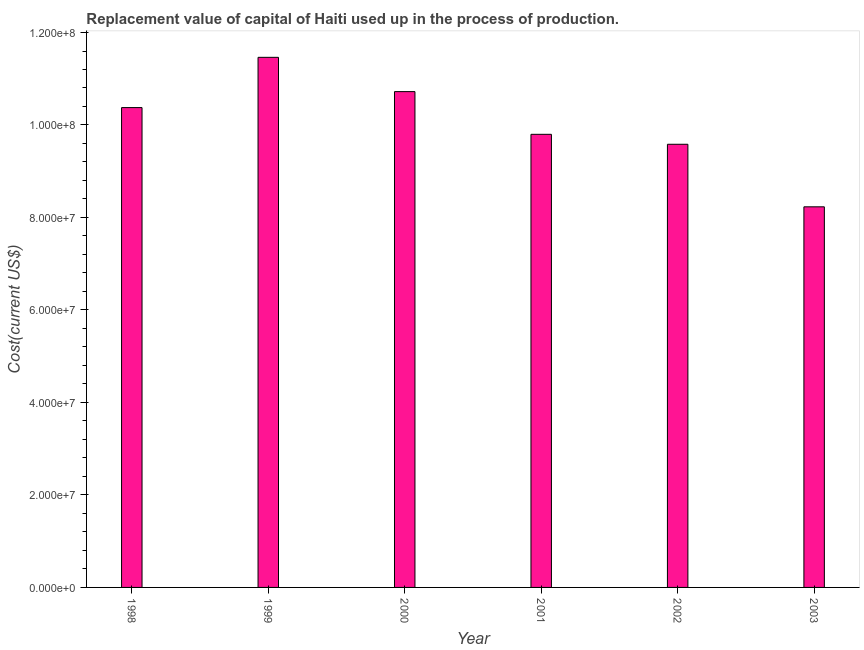Does the graph contain grids?
Ensure brevity in your answer.  No. What is the title of the graph?
Provide a succinct answer. Replacement value of capital of Haiti used up in the process of production. What is the label or title of the X-axis?
Keep it short and to the point. Year. What is the label or title of the Y-axis?
Offer a very short reply. Cost(current US$). What is the consumption of fixed capital in 2003?
Your response must be concise. 8.23e+07. Across all years, what is the maximum consumption of fixed capital?
Your answer should be compact. 1.15e+08. Across all years, what is the minimum consumption of fixed capital?
Your response must be concise. 8.23e+07. In which year was the consumption of fixed capital maximum?
Keep it short and to the point. 1999. In which year was the consumption of fixed capital minimum?
Offer a terse response. 2003. What is the sum of the consumption of fixed capital?
Your answer should be compact. 6.02e+08. What is the difference between the consumption of fixed capital in 1998 and 2000?
Your answer should be very brief. -3.45e+06. What is the average consumption of fixed capital per year?
Your answer should be very brief. 1.00e+08. What is the median consumption of fixed capital?
Your answer should be compact. 1.01e+08. Do a majority of the years between 1998 and 2000 (inclusive) have consumption of fixed capital greater than 72000000 US$?
Make the answer very short. Yes. What is the ratio of the consumption of fixed capital in 1999 to that in 2003?
Make the answer very short. 1.39. Is the consumption of fixed capital in 1998 less than that in 2000?
Make the answer very short. Yes. Is the difference between the consumption of fixed capital in 1998 and 2000 greater than the difference between any two years?
Give a very brief answer. No. What is the difference between the highest and the second highest consumption of fixed capital?
Give a very brief answer. 7.41e+06. Is the sum of the consumption of fixed capital in 2001 and 2002 greater than the maximum consumption of fixed capital across all years?
Ensure brevity in your answer.  Yes. What is the difference between the highest and the lowest consumption of fixed capital?
Offer a terse response. 3.23e+07. In how many years, is the consumption of fixed capital greater than the average consumption of fixed capital taken over all years?
Offer a very short reply. 3. Are all the bars in the graph horizontal?
Make the answer very short. No. What is the difference between two consecutive major ticks on the Y-axis?
Your answer should be very brief. 2.00e+07. Are the values on the major ticks of Y-axis written in scientific E-notation?
Keep it short and to the point. Yes. What is the Cost(current US$) of 1998?
Provide a short and direct response. 1.04e+08. What is the Cost(current US$) of 1999?
Keep it short and to the point. 1.15e+08. What is the Cost(current US$) of 2000?
Your response must be concise. 1.07e+08. What is the Cost(current US$) in 2001?
Make the answer very short. 9.80e+07. What is the Cost(current US$) of 2002?
Your answer should be very brief. 9.58e+07. What is the Cost(current US$) of 2003?
Offer a terse response. 8.23e+07. What is the difference between the Cost(current US$) in 1998 and 1999?
Provide a short and direct response. -1.09e+07. What is the difference between the Cost(current US$) in 1998 and 2000?
Provide a succinct answer. -3.45e+06. What is the difference between the Cost(current US$) in 1998 and 2001?
Offer a very short reply. 5.78e+06. What is the difference between the Cost(current US$) in 1998 and 2002?
Keep it short and to the point. 7.93e+06. What is the difference between the Cost(current US$) in 1998 and 2003?
Your response must be concise. 2.15e+07. What is the difference between the Cost(current US$) in 1999 and 2000?
Make the answer very short. 7.41e+06. What is the difference between the Cost(current US$) in 1999 and 2001?
Give a very brief answer. 1.67e+07. What is the difference between the Cost(current US$) in 1999 and 2002?
Give a very brief answer. 1.88e+07. What is the difference between the Cost(current US$) in 1999 and 2003?
Keep it short and to the point. 3.23e+07. What is the difference between the Cost(current US$) in 2000 and 2001?
Your answer should be very brief. 9.24e+06. What is the difference between the Cost(current US$) in 2000 and 2002?
Ensure brevity in your answer.  1.14e+07. What is the difference between the Cost(current US$) in 2000 and 2003?
Offer a terse response. 2.49e+07. What is the difference between the Cost(current US$) in 2001 and 2002?
Give a very brief answer. 2.15e+06. What is the difference between the Cost(current US$) in 2001 and 2003?
Keep it short and to the point. 1.57e+07. What is the difference between the Cost(current US$) in 2002 and 2003?
Provide a short and direct response. 1.35e+07. What is the ratio of the Cost(current US$) in 1998 to that in 1999?
Your response must be concise. 0.91. What is the ratio of the Cost(current US$) in 1998 to that in 2001?
Provide a short and direct response. 1.06. What is the ratio of the Cost(current US$) in 1998 to that in 2002?
Give a very brief answer. 1.08. What is the ratio of the Cost(current US$) in 1998 to that in 2003?
Your answer should be compact. 1.26. What is the ratio of the Cost(current US$) in 1999 to that in 2000?
Your answer should be very brief. 1.07. What is the ratio of the Cost(current US$) in 1999 to that in 2001?
Your answer should be very brief. 1.17. What is the ratio of the Cost(current US$) in 1999 to that in 2002?
Your answer should be compact. 1.2. What is the ratio of the Cost(current US$) in 1999 to that in 2003?
Keep it short and to the point. 1.39. What is the ratio of the Cost(current US$) in 2000 to that in 2001?
Provide a short and direct response. 1.09. What is the ratio of the Cost(current US$) in 2000 to that in 2002?
Make the answer very short. 1.12. What is the ratio of the Cost(current US$) in 2000 to that in 2003?
Provide a short and direct response. 1.3. What is the ratio of the Cost(current US$) in 2001 to that in 2002?
Give a very brief answer. 1.02. What is the ratio of the Cost(current US$) in 2001 to that in 2003?
Your answer should be compact. 1.19. What is the ratio of the Cost(current US$) in 2002 to that in 2003?
Keep it short and to the point. 1.16. 